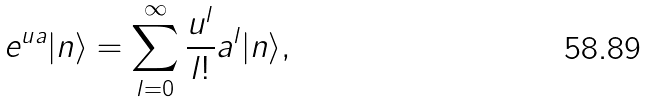<formula> <loc_0><loc_0><loc_500><loc_500>e ^ { u a } | n \rangle = \sum _ { l = 0 } ^ { \infty } \frac { u ^ { l } } { l ! } a ^ { l } | n \rangle ,</formula> 